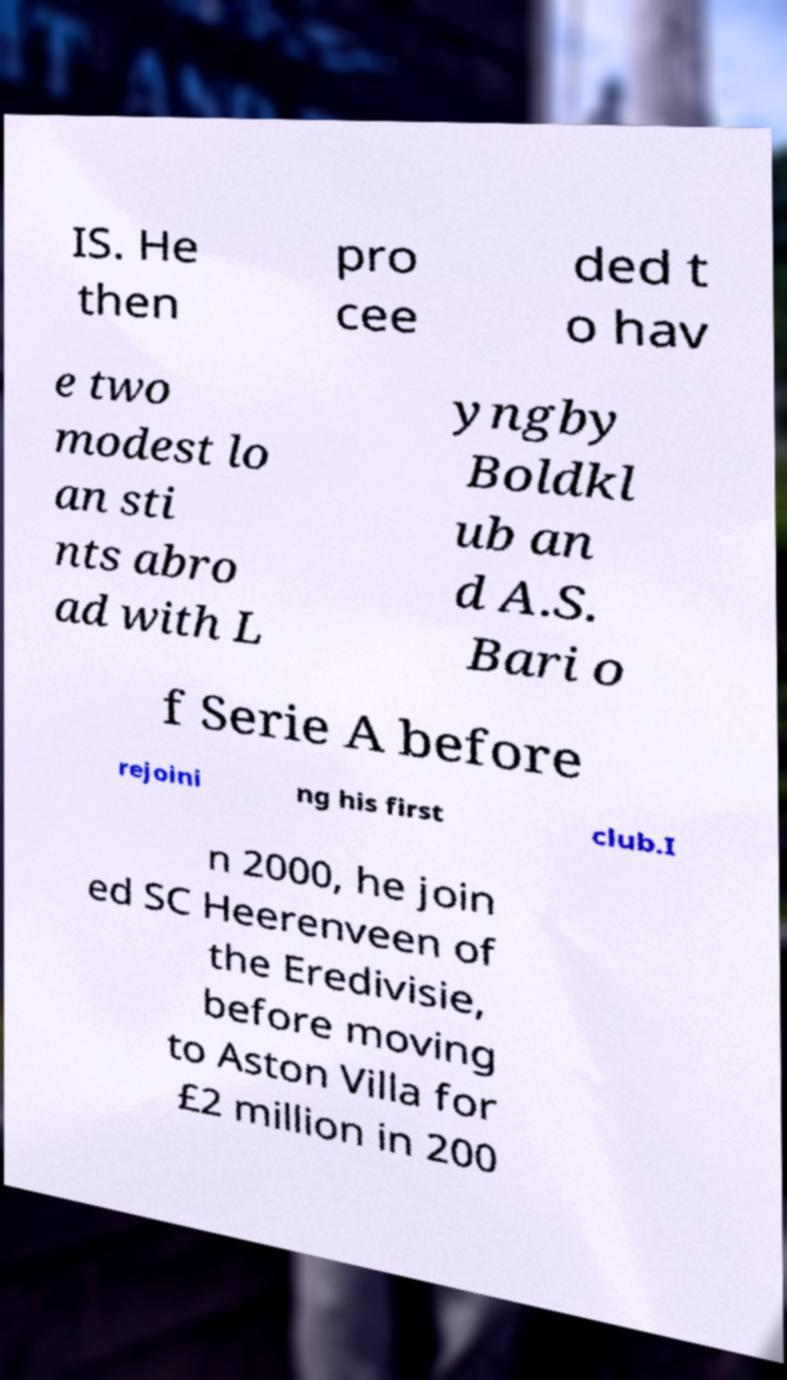For documentation purposes, I need the text within this image transcribed. Could you provide that? IS. He then pro cee ded t o hav e two modest lo an sti nts abro ad with L yngby Boldkl ub an d A.S. Bari o f Serie A before rejoini ng his first club.I n 2000, he join ed SC Heerenveen of the Eredivisie, before moving to Aston Villa for £2 million in 200 